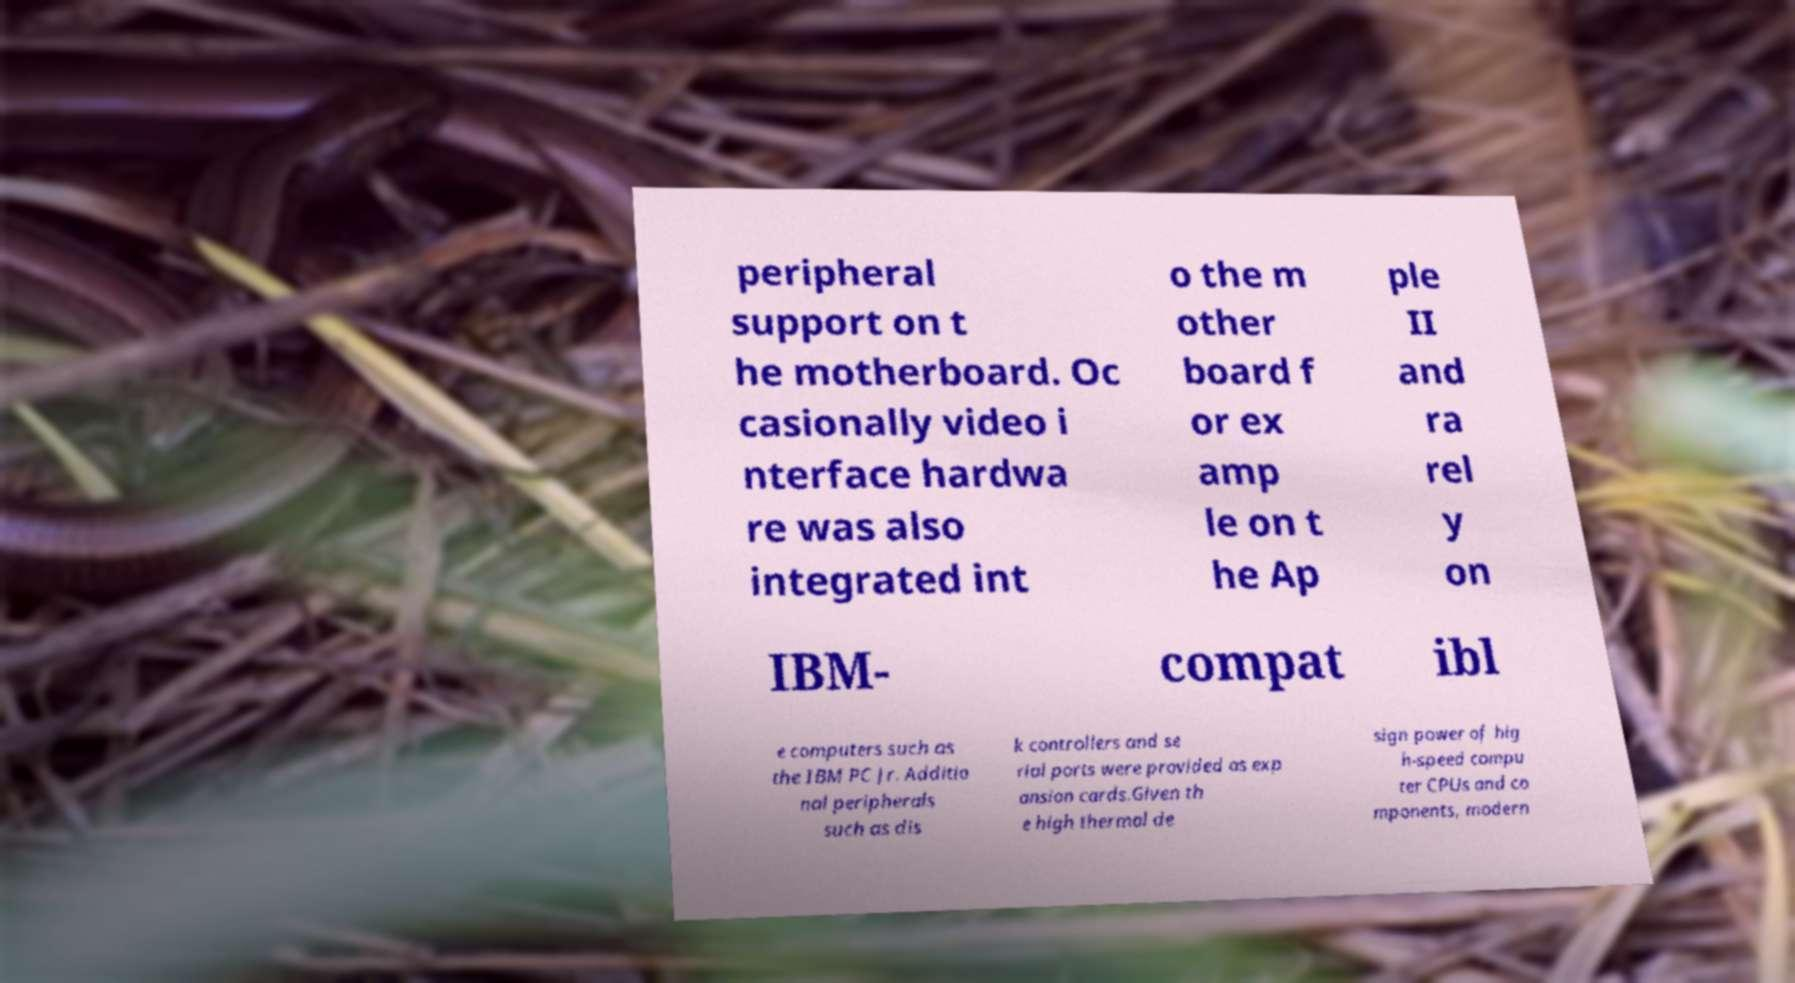There's text embedded in this image that I need extracted. Can you transcribe it verbatim? peripheral support on t he motherboard. Oc casionally video i nterface hardwa re was also integrated int o the m other board f or ex amp le on t he Ap ple II and ra rel y on IBM- compat ibl e computers such as the IBM PC Jr. Additio nal peripherals such as dis k controllers and se rial ports were provided as exp ansion cards.Given th e high thermal de sign power of hig h-speed compu ter CPUs and co mponents, modern 